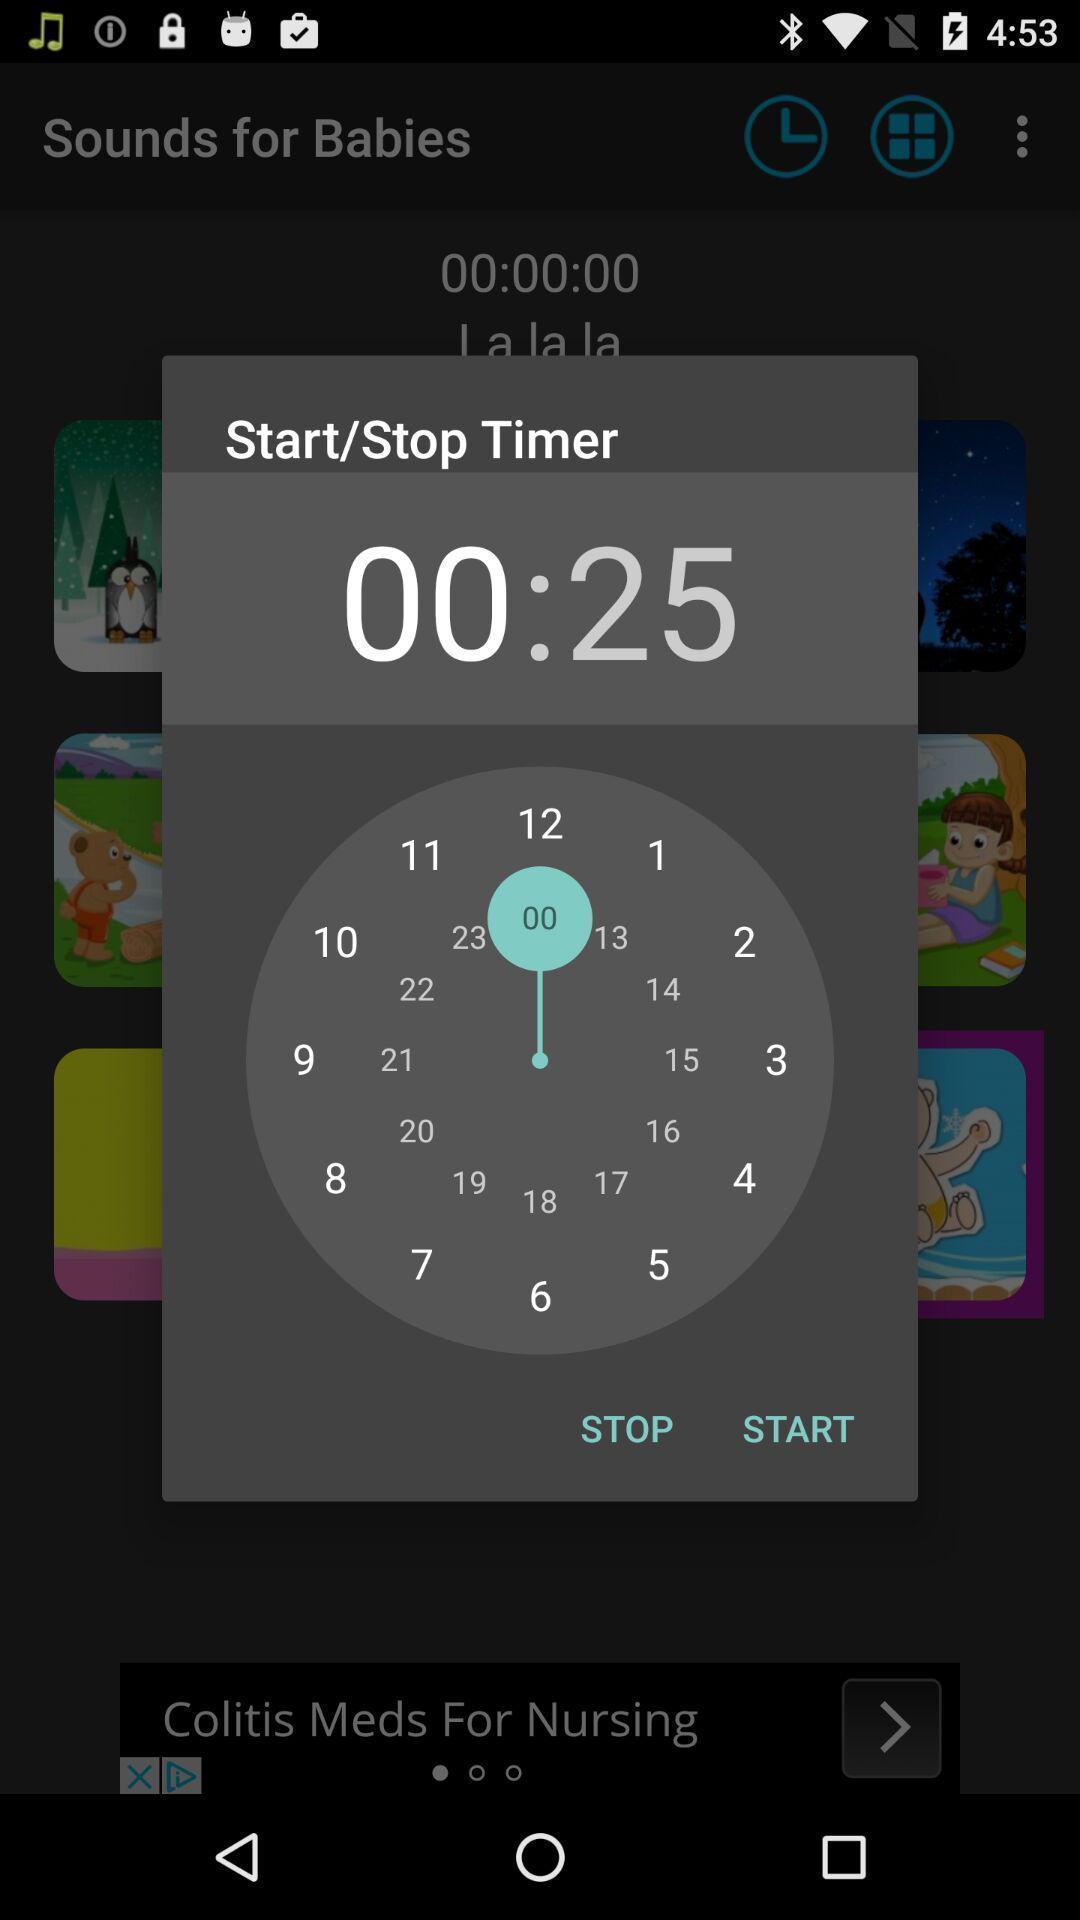Tell me about the visual elements in this screen capture. Pop up window to set timer for sleep. 